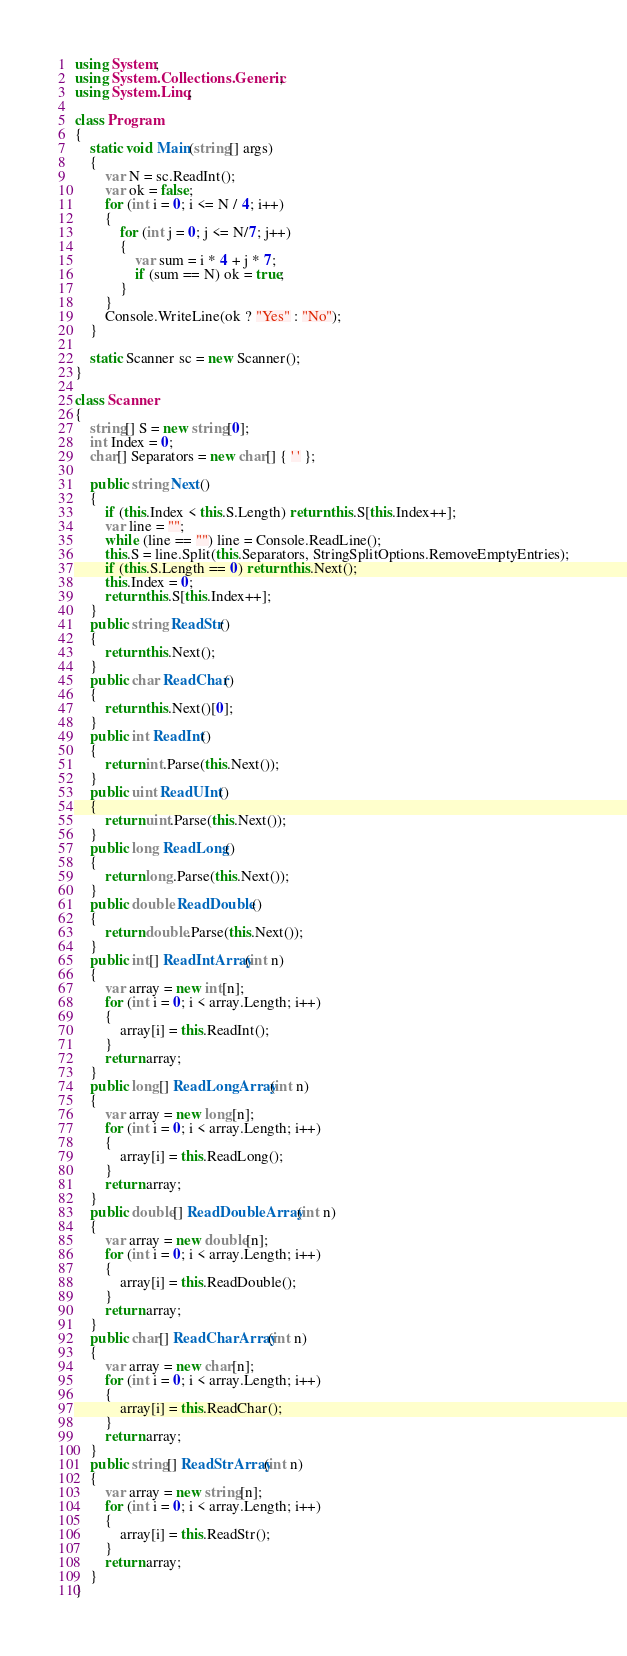<code> <loc_0><loc_0><loc_500><loc_500><_C#_>using System;
using System.Collections.Generic;
using System.Linq;

class Program
{
    static void Main(string[] args)
    {
        var N = sc.ReadInt();
        var ok = false;
        for (int i = 0; i <= N / 4; i++)
        {
            for (int j = 0; j <= N/7; j++)
            {
                var sum = i * 4 + j * 7;
                if (sum == N) ok = true;
            }
        }
        Console.WriteLine(ok ? "Yes" : "No");
    }

    static Scanner sc = new Scanner();
}

class Scanner
{
    string[] S = new string[0];
    int Index = 0;
    char[] Separators = new char[] { ' ' };

    public string Next()
    {
        if (this.Index < this.S.Length) return this.S[this.Index++];
        var line = "";
        while (line == "") line = Console.ReadLine();
        this.S = line.Split(this.Separators, StringSplitOptions.RemoveEmptyEntries);
        if (this.S.Length == 0) return this.Next();
        this.Index = 0;
        return this.S[this.Index++];
    }
    public string ReadStr()
    {
        return this.Next();
    }
    public char ReadChar()
    {
        return this.Next()[0];
    }
    public int ReadInt()
    {
        return int.Parse(this.Next());
    }
    public uint ReadUInt()
    {
        return uint.Parse(this.Next());
    }
    public long ReadLong()
    {
        return long.Parse(this.Next());
    }
    public double ReadDouble()
    {
        return double.Parse(this.Next());
    }
    public int[] ReadIntArray(int n)
    {
        var array = new int[n];
        for (int i = 0; i < array.Length; i++)
        {
            array[i] = this.ReadInt();
        }
        return array;
    }
    public long[] ReadLongArray(int n)
    {
        var array = new long[n];
        for (int i = 0; i < array.Length; i++)
        {
            array[i] = this.ReadLong();
        }
        return array;
    }
    public double[] ReadDoubleArray(int n)
    {
        var array = new double[n];
        for (int i = 0; i < array.Length; i++)
        {
            array[i] = this.ReadDouble();
        }
        return array;
    }
    public char[] ReadCharArray(int n)
    {
        var array = new char[n];
        for (int i = 0; i < array.Length; i++)
        {
            array[i] = this.ReadChar();
        }
        return array;
    }
    public string[] ReadStrArray(int n)
    {
        var array = new string[n];
        for (int i = 0; i < array.Length; i++)
        {
            array[i] = this.ReadStr();
        }
        return array;
    }
}
</code> 